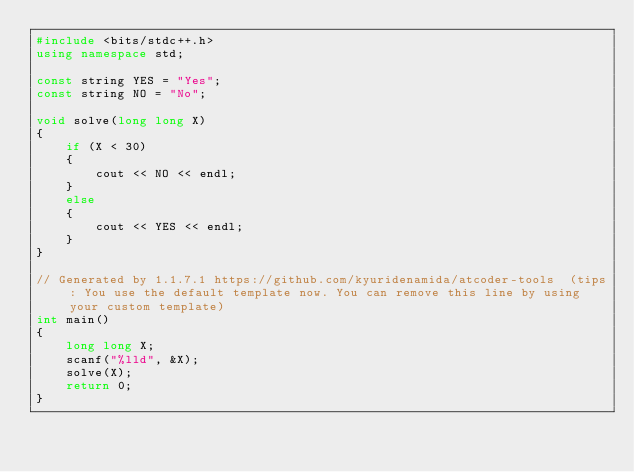<code> <loc_0><loc_0><loc_500><loc_500><_C++_>#include <bits/stdc++.h>
using namespace std;

const string YES = "Yes";
const string NO = "No";

void solve(long long X)
{
    if (X < 30)
    {
        cout << NO << endl;
    }
    else
    {
        cout << YES << endl;
    }
}

// Generated by 1.1.7.1 https://github.com/kyuridenamida/atcoder-tools  (tips: You use the default template now. You can remove this line by using your custom template)
int main()
{
    long long X;
    scanf("%lld", &X);
    solve(X);
    return 0;
}
</code> 